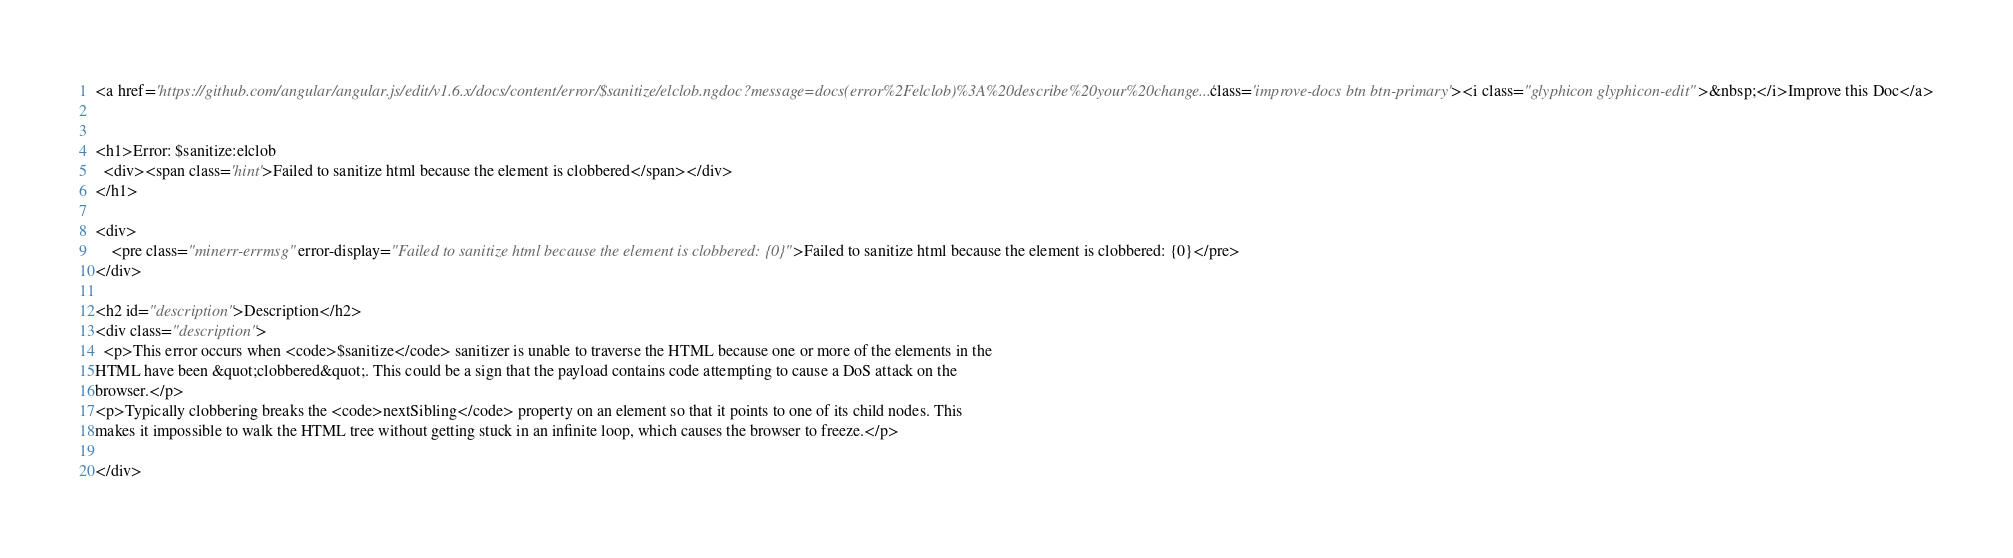<code> <loc_0><loc_0><loc_500><loc_500><_HTML_><a href='https://github.com/angular/angular.js/edit/v1.6.x/docs/content/error/$sanitize/elclob.ngdoc?message=docs(error%2Felclob)%3A%20describe%20your%20change...' class='improve-docs btn btn-primary'><i class="glyphicon glyphicon-edit">&nbsp;</i>Improve this Doc</a>


<h1>Error: $sanitize:elclob
  <div><span class='hint'>Failed to sanitize html because the element is clobbered</span></div>
</h1>

<div>
    <pre class="minerr-errmsg" error-display="Failed to sanitize html because the element is clobbered: {0}">Failed to sanitize html because the element is clobbered: {0}</pre>
</div>

<h2 id="description">Description</h2>
<div class="description">
  <p>This error occurs when <code>$sanitize</code> sanitizer is unable to traverse the HTML because one or more of the elements in the
HTML have been &quot;clobbered&quot;. This could be a sign that the payload contains code attempting to cause a DoS attack on the
browser.</p>
<p>Typically clobbering breaks the <code>nextSibling</code> property on an element so that it points to one of its child nodes. This
makes it impossible to walk the HTML tree without getting stuck in an infinite loop, which causes the browser to freeze.</p>

</div>


</code> 